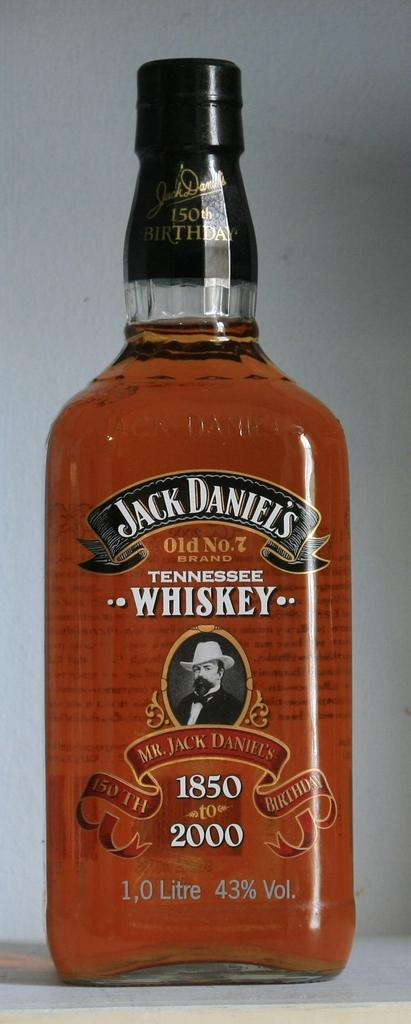What object is present in the image? There is a bottle in the image. What can be seen on the bottle besides the bottle itself? There are words written on the bottle and a picture of a man. What type of cake is being ordered by the man in the image? There is no cake present in the image, nor is there any indication that a man is ordering anything. 